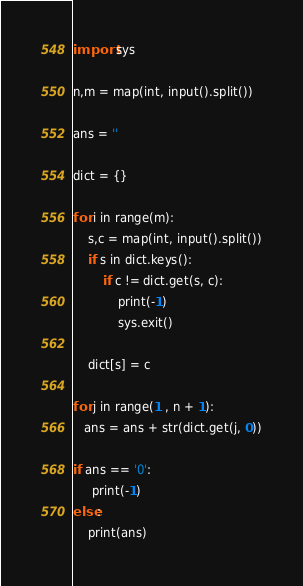<code> <loc_0><loc_0><loc_500><loc_500><_Python_>import sys

n,m = map(int, input().split())

ans = ''

dict = {}

for i in range(m):
    s,c = map(int, input().split())
    if s in dict.keys():
        if c != dict.get(s, c):
            print(-1)
            sys.exit()

    dict[s] = c 

for j in range(1 , n + 1):
   ans = ans + str(dict.get(j, 0))

if ans == '0':
     print(-1)
else:
    print(ans)
</code> 